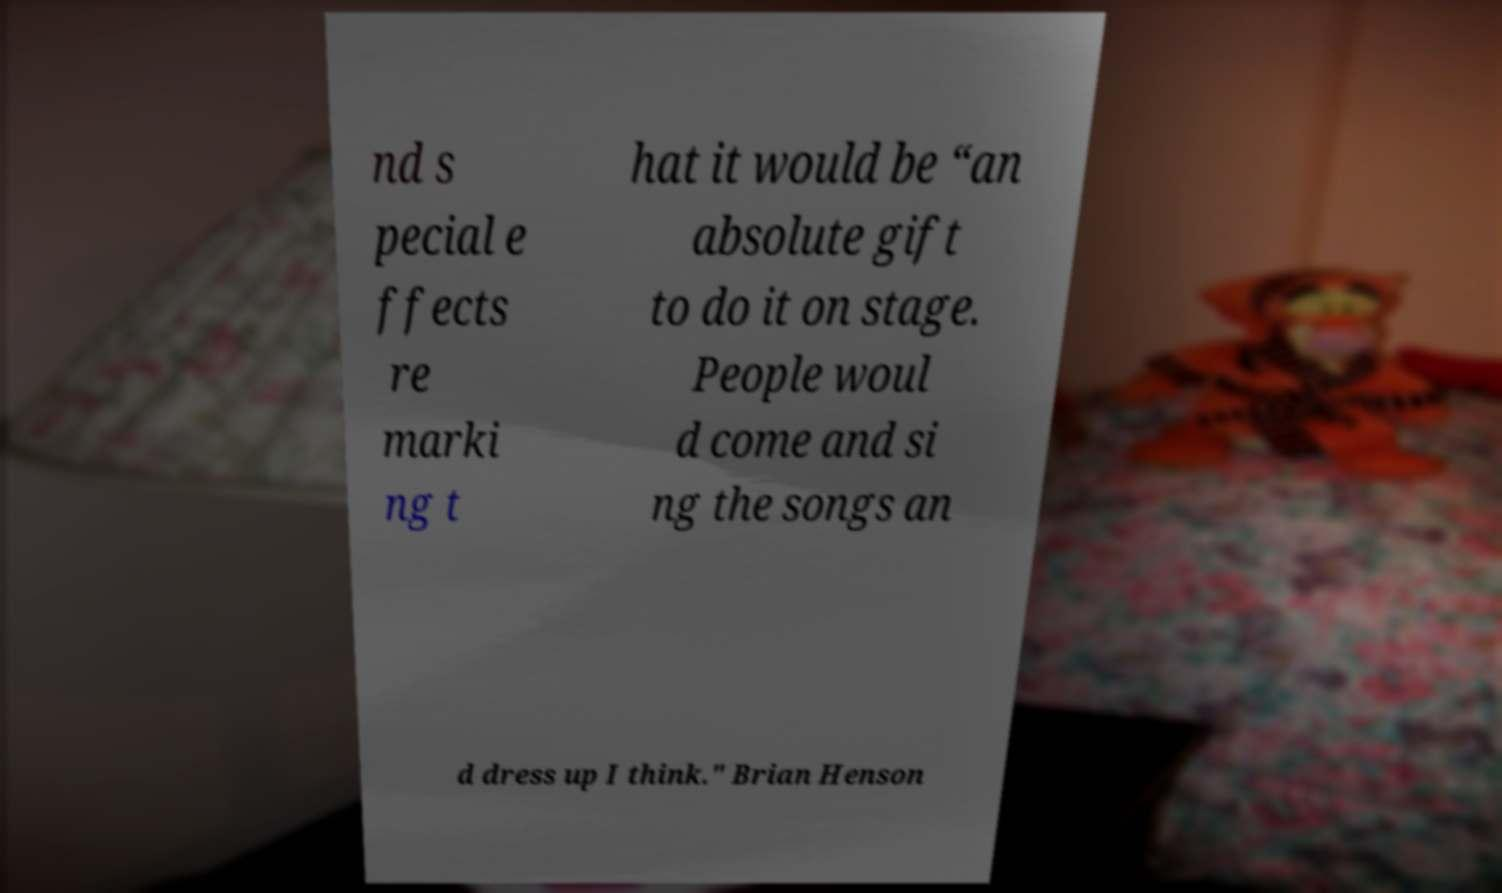Could you extract and type out the text from this image? nd s pecial e ffects re marki ng t hat it would be “an absolute gift to do it on stage. People woul d come and si ng the songs an d dress up I think." Brian Henson 